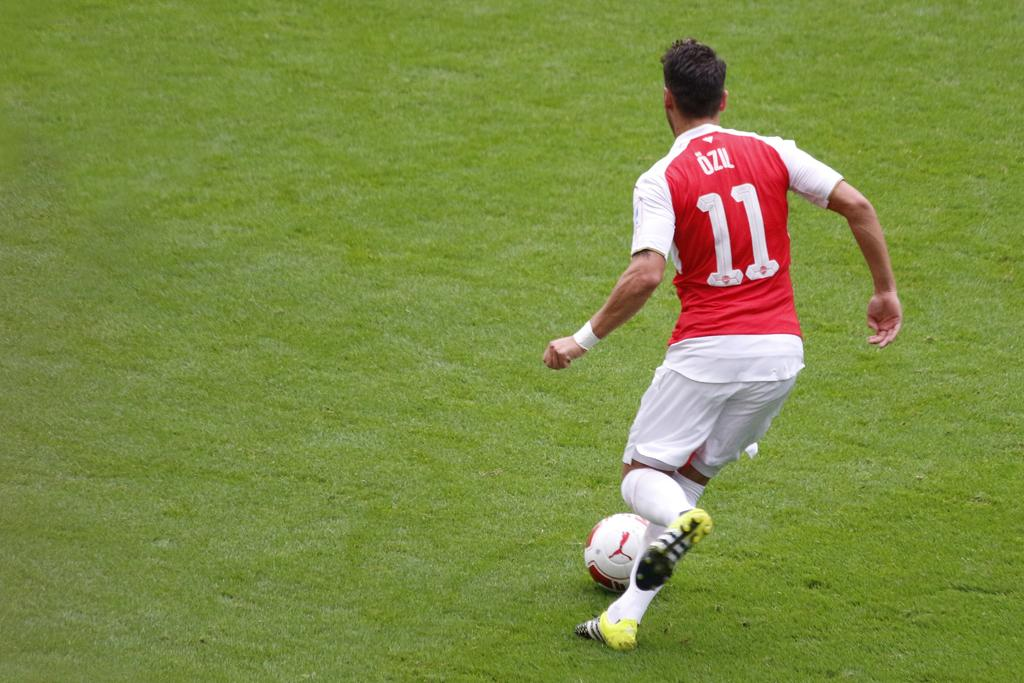Who is present in the image? There is a person in the image. What is the person doing in the image? The person is running in the image. What type of terrain is the person running on? The person is running on grassland in the image. What object is visible in front of the person? There is a ball in the image, and it is before the person. What type of kite is the person holding while running in the image? There is no kite present in the image; the person is running with a ball before them. What type of club is the person carrying while running in the image? There is no club present in the image; the person is running with a ball before them. 